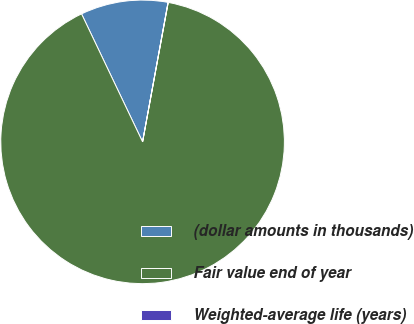Convert chart to OTSL. <chart><loc_0><loc_0><loc_500><loc_500><pie_chart><fcel>(dollar amounts in thousands)<fcel>Fair value end of year<fcel>Weighted-average life (years)<nl><fcel>9.96%<fcel>90.02%<fcel>0.02%<nl></chart> 